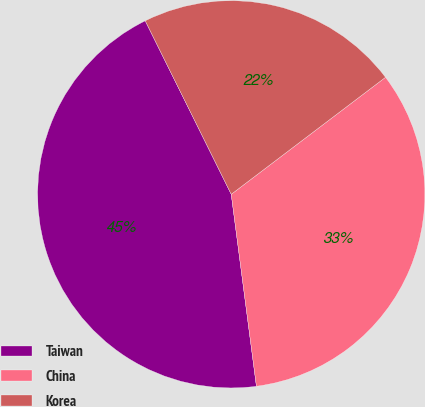<chart> <loc_0><loc_0><loc_500><loc_500><pie_chart><fcel>Taiwan<fcel>China<fcel>Korea<nl><fcel>44.75%<fcel>33.25%<fcel>22.0%<nl></chart> 